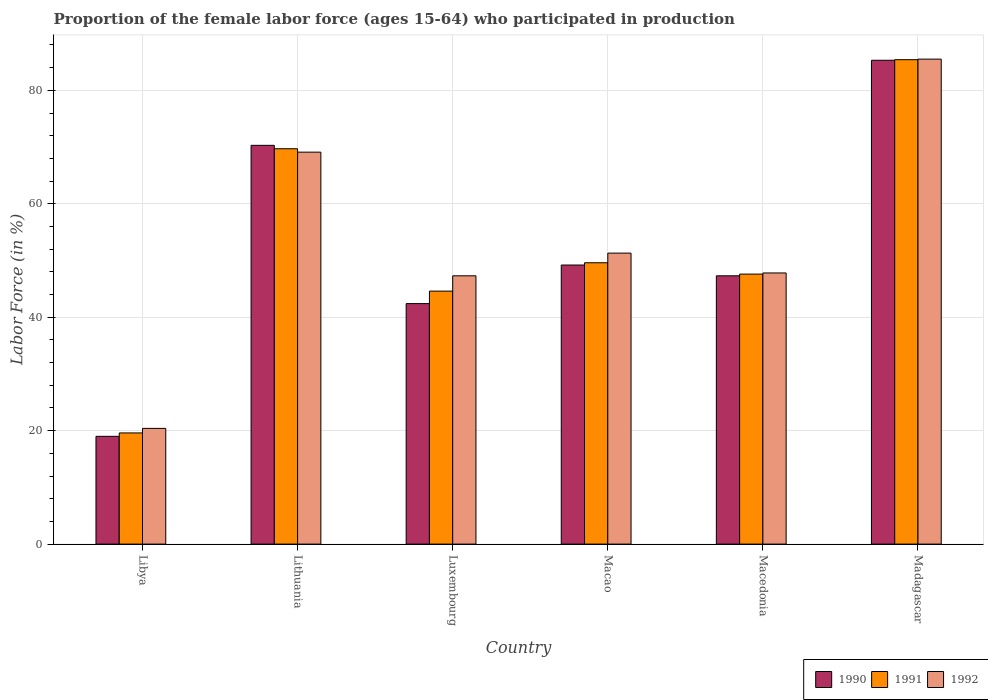How many groups of bars are there?
Give a very brief answer. 6. Are the number of bars per tick equal to the number of legend labels?
Provide a short and direct response. Yes. How many bars are there on the 5th tick from the left?
Your response must be concise. 3. How many bars are there on the 1st tick from the right?
Your answer should be compact. 3. What is the label of the 6th group of bars from the left?
Give a very brief answer. Madagascar. What is the proportion of the female labor force who participated in production in 1992 in Macao?
Provide a succinct answer. 51.3. Across all countries, what is the maximum proportion of the female labor force who participated in production in 1992?
Keep it short and to the point. 85.5. Across all countries, what is the minimum proportion of the female labor force who participated in production in 1991?
Your response must be concise. 19.6. In which country was the proportion of the female labor force who participated in production in 1992 maximum?
Give a very brief answer. Madagascar. In which country was the proportion of the female labor force who participated in production in 1991 minimum?
Your answer should be very brief. Libya. What is the total proportion of the female labor force who participated in production in 1992 in the graph?
Offer a very short reply. 321.4. What is the difference between the proportion of the female labor force who participated in production in 1991 in Luxembourg and that in Madagascar?
Provide a short and direct response. -40.8. What is the difference between the proportion of the female labor force who participated in production in 1992 in Madagascar and the proportion of the female labor force who participated in production in 1990 in Lithuania?
Make the answer very short. 15.2. What is the average proportion of the female labor force who participated in production in 1991 per country?
Your answer should be very brief. 52.75. What is the difference between the proportion of the female labor force who participated in production of/in 1992 and proportion of the female labor force who participated in production of/in 1991 in Macao?
Ensure brevity in your answer.  1.7. In how many countries, is the proportion of the female labor force who participated in production in 1990 greater than 40 %?
Give a very brief answer. 5. What is the ratio of the proportion of the female labor force who participated in production in 1991 in Libya to that in Macedonia?
Your answer should be very brief. 0.41. Is the proportion of the female labor force who participated in production in 1991 in Macedonia less than that in Madagascar?
Ensure brevity in your answer.  Yes. What is the difference between the highest and the second highest proportion of the female labor force who participated in production in 1991?
Your response must be concise. -20.1. What is the difference between the highest and the lowest proportion of the female labor force who participated in production in 1991?
Offer a very short reply. 65.8. In how many countries, is the proportion of the female labor force who participated in production in 1991 greater than the average proportion of the female labor force who participated in production in 1991 taken over all countries?
Your answer should be compact. 2. Is the sum of the proportion of the female labor force who participated in production in 1990 in Lithuania and Madagascar greater than the maximum proportion of the female labor force who participated in production in 1992 across all countries?
Make the answer very short. Yes. Are the values on the major ticks of Y-axis written in scientific E-notation?
Ensure brevity in your answer.  No. How are the legend labels stacked?
Give a very brief answer. Horizontal. What is the title of the graph?
Your answer should be very brief. Proportion of the female labor force (ages 15-64) who participated in production. Does "2010" appear as one of the legend labels in the graph?
Make the answer very short. No. What is the label or title of the Y-axis?
Give a very brief answer. Labor Force (in %). What is the Labor Force (in %) in 1991 in Libya?
Ensure brevity in your answer.  19.6. What is the Labor Force (in %) of 1992 in Libya?
Make the answer very short. 20.4. What is the Labor Force (in %) in 1990 in Lithuania?
Your response must be concise. 70.3. What is the Labor Force (in %) in 1991 in Lithuania?
Your answer should be compact. 69.7. What is the Labor Force (in %) of 1992 in Lithuania?
Make the answer very short. 69.1. What is the Labor Force (in %) of 1990 in Luxembourg?
Your response must be concise. 42.4. What is the Labor Force (in %) of 1991 in Luxembourg?
Your answer should be very brief. 44.6. What is the Labor Force (in %) of 1992 in Luxembourg?
Provide a short and direct response. 47.3. What is the Labor Force (in %) in 1990 in Macao?
Provide a succinct answer. 49.2. What is the Labor Force (in %) in 1991 in Macao?
Make the answer very short. 49.6. What is the Labor Force (in %) in 1992 in Macao?
Give a very brief answer. 51.3. What is the Labor Force (in %) of 1990 in Macedonia?
Give a very brief answer. 47.3. What is the Labor Force (in %) in 1991 in Macedonia?
Offer a very short reply. 47.6. What is the Labor Force (in %) in 1992 in Macedonia?
Make the answer very short. 47.8. What is the Labor Force (in %) in 1990 in Madagascar?
Ensure brevity in your answer.  85.3. What is the Labor Force (in %) in 1991 in Madagascar?
Your response must be concise. 85.4. What is the Labor Force (in %) in 1992 in Madagascar?
Make the answer very short. 85.5. Across all countries, what is the maximum Labor Force (in %) of 1990?
Your answer should be compact. 85.3. Across all countries, what is the maximum Labor Force (in %) of 1991?
Your answer should be compact. 85.4. Across all countries, what is the maximum Labor Force (in %) of 1992?
Make the answer very short. 85.5. Across all countries, what is the minimum Labor Force (in %) of 1990?
Make the answer very short. 19. Across all countries, what is the minimum Labor Force (in %) of 1991?
Your answer should be very brief. 19.6. Across all countries, what is the minimum Labor Force (in %) in 1992?
Your response must be concise. 20.4. What is the total Labor Force (in %) of 1990 in the graph?
Keep it short and to the point. 313.5. What is the total Labor Force (in %) of 1991 in the graph?
Make the answer very short. 316.5. What is the total Labor Force (in %) of 1992 in the graph?
Ensure brevity in your answer.  321.4. What is the difference between the Labor Force (in %) in 1990 in Libya and that in Lithuania?
Keep it short and to the point. -51.3. What is the difference between the Labor Force (in %) of 1991 in Libya and that in Lithuania?
Offer a very short reply. -50.1. What is the difference between the Labor Force (in %) in 1992 in Libya and that in Lithuania?
Your response must be concise. -48.7. What is the difference between the Labor Force (in %) of 1990 in Libya and that in Luxembourg?
Provide a succinct answer. -23.4. What is the difference between the Labor Force (in %) in 1991 in Libya and that in Luxembourg?
Make the answer very short. -25. What is the difference between the Labor Force (in %) in 1992 in Libya and that in Luxembourg?
Ensure brevity in your answer.  -26.9. What is the difference between the Labor Force (in %) in 1990 in Libya and that in Macao?
Offer a terse response. -30.2. What is the difference between the Labor Force (in %) in 1992 in Libya and that in Macao?
Ensure brevity in your answer.  -30.9. What is the difference between the Labor Force (in %) of 1990 in Libya and that in Macedonia?
Ensure brevity in your answer.  -28.3. What is the difference between the Labor Force (in %) in 1991 in Libya and that in Macedonia?
Your response must be concise. -28. What is the difference between the Labor Force (in %) in 1992 in Libya and that in Macedonia?
Make the answer very short. -27.4. What is the difference between the Labor Force (in %) in 1990 in Libya and that in Madagascar?
Keep it short and to the point. -66.3. What is the difference between the Labor Force (in %) of 1991 in Libya and that in Madagascar?
Your answer should be very brief. -65.8. What is the difference between the Labor Force (in %) in 1992 in Libya and that in Madagascar?
Ensure brevity in your answer.  -65.1. What is the difference between the Labor Force (in %) of 1990 in Lithuania and that in Luxembourg?
Offer a terse response. 27.9. What is the difference between the Labor Force (in %) of 1991 in Lithuania and that in Luxembourg?
Keep it short and to the point. 25.1. What is the difference between the Labor Force (in %) of 1992 in Lithuania and that in Luxembourg?
Make the answer very short. 21.8. What is the difference between the Labor Force (in %) of 1990 in Lithuania and that in Macao?
Your answer should be very brief. 21.1. What is the difference between the Labor Force (in %) of 1991 in Lithuania and that in Macao?
Your answer should be very brief. 20.1. What is the difference between the Labor Force (in %) of 1992 in Lithuania and that in Macao?
Give a very brief answer. 17.8. What is the difference between the Labor Force (in %) of 1990 in Lithuania and that in Macedonia?
Give a very brief answer. 23. What is the difference between the Labor Force (in %) in 1991 in Lithuania and that in Macedonia?
Give a very brief answer. 22.1. What is the difference between the Labor Force (in %) of 1992 in Lithuania and that in Macedonia?
Make the answer very short. 21.3. What is the difference between the Labor Force (in %) of 1990 in Lithuania and that in Madagascar?
Keep it short and to the point. -15. What is the difference between the Labor Force (in %) in 1991 in Lithuania and that in Madagascar?
Your answer should be compact. -15.7. What is the difference between the Labor Force (in %) in 1992 in Lithuania and that in Madagascar?
Keep it short and to the point. -16.4. What is the difference between the Labor Force (in %) in 1990 in Luxembourg and that in Macao?
Keep it short and to the point. -6.8. What is the difference between the Labor Force (in %) of 1992 in Luxembourg and that in Macao?
Provide a short and direct response. -4. What is the difference between the Labor Force (in %) of 1990 in Luxembourg and that in Macedonia?
Make the answer very short. -4.9. What is the difference between the Labor Force (in %) in 1990 in Luxembourg and that in Madagascar?
Provide a short and direct response. -42.9. What is the difference between the Labor Force (in %) of 1991 in Luxembourg and that in Madagascar?
Offer a terse response. -40.8. What is the difference between the Labor Force (in %) of 1992 in Luxembourg and that in Madagascar?
Your answer should be compact. -38.2. What is the difference between the Labor Force (in %) of 1991 in Macao and that in Macedonia?
Provide a short and direct response. 2. What is the difference between the Labor Force (in %) of 1990 in Macao and that in Madagascar?
Ensure brevity in your answer.  -36.1. What is the difference between the Labor Force (in %) in 1991 in Macao and that in Madagascar?
Ensure brevity in your answer.  -35.8. What is the difference between the Labor Force (in %) of 1992 in Macao and that in Madagascar?
Your answer should be very brief. -34.2. What is the difference between the Labor Force (in %) in 1990 in Macedonia and that in Madagascar?
Your answer should be compact. -38. What is the difference between the Labor Force (in %) of 1991 in Macedonia and that in Madagascar?
Your answer should be compact. -37.8. What is the difference between the Labor Force (in %) in 1992 in Macedonia and that in Madagascar?
Keep it short and to the point. -37.7. What is the difference between the Labor Force (in %) of 1990 in Libya and the Labor Force (in %) of 1991 in Lithuania?
Keep it short and to the point. -50.7. What is the difference between the Labor Force (in %) in 1990 in Libya and the Labor Force (in %) in 1992 in Lithuania?
Provide a succinct answer. -50.1. What is the difference between the Labor Force (in %) of 1991 in Libya and the Labor Force (in %) of 1992 in Lithuania?
Your answer should be compact. -49.5. What is the difference between the Labor Force (in %) of 1990 in Libya and the Labor Force (in %) of 1991 in Luxembourg?
Your response must be concise. -25.6. What is the difference between the Labor Force (in %) in 1990 in Libya and the Labor Force (in %) in 1992 in Luxembourg?
Your response must be concise. -28.3. What is the difference between the Labor Force (in %) of 1991 in Libya and the Labor Force (in %) of 1992 in Luxembourg?
Your answer should be very brief. -27.7. What is the difference between the Labor Force (in %) in 1990 in Libya and the Labor Force (in %) in 1991 in Macao?
Give a very brief answer. -30.6. What is the difference between the Labor Force (in %) of 1990 in Libya and the Labor Force (in %) of 1992 in Macao?
Offer a terse response. -32.3. What is the difference between the Labor Force (in %) of 1991 in Libya and the Labor Force (in %) of 1992 in Macao?
Offer a very short reply. -31.7. What is the difference between the Labor Force (in %) in 1990 in Libya and the Labor Force (in %) in 1991 in Macedonia?
Offer a very short reply. -28.6. What is the difference between the Labor Force (in %) in 1990 in Libya and the Labor Force (in %) in 1992 in Macedonia?
Offer a very short reply. -28.8. What is the difference between the Labor Force (in %) of 1991 in Libya and the Labor Force (in %) of 1992 in Macedonia?
Your answer should be very brief. -28.2. What is the difference between the Labor Force (in %) in 1990 in Libya and the Labor Force (in %) in 1991 in Madagascar?
Keep it short and to the point. -66.4. What is the difference between the Labor Force (in %) of 1990 in Libya and the Labor Force (in %) of 1992 in Madagascar?
Provide a succinct answer. -66.5. What is the difference between the Labor Force (in %) in 1991 in Libya and the Labor Force (in %) in 1992 in Madagascar?
Your response must be concise. -65.9. What is the difference between the Labor Force (in %) in 1990 in Lithuania and the Labor Force (in %) in 1991 in Luxembourg?
Your answer should be compact. 25.7. What is the difference between the Labor Force (in %) of 1990 in Lithuania and the Labor Force (in %) of 1992 in Luxembourg?
Your answer should be very brief. 23. What is the difference between the Labor Force (in %) of 1991 in Lithuania and the Labor Force (in %) of 1992 in Luxembourg?
Offer a terse response. 22.4. What is the difference between the Labor Force (in %) in 1990 in Lithuania and the Labor Force (in %) in 1991 in Macao?
Your answer should be compact. 20.7. What is the difference between the Labor Force (in %) of 1990 in Lithuania and the Labor Force (in %) of 1992 in Macao?
Your answer should be very brief. 19. What is the difference between the Labor Force (in %) of 1990 in Lithuania and the Labor Force (in %) of 1991 in Macedonia?
Offer a very short reply. 22.7. What is the difference between the Labor Force (in %) of 1991 in Lithuania and the Labor Force (in %) of 1992 in Macedonia?
Provide a succinct answer. 21.9. What is the difference between the Labor Force (in %) in 1990 in Lithuania and the Labor Force (in %) in 1991 in Madagascar?
Your answer should be very brief. -15.1. What is the difference between the Labor Force (in %) in 1990 in Lithuania and the Labor Force (in %) in 1992 in Madagascar?
Offer a very short reply. -15.2. What is the difference between the Labor Force (in %) of 1991 in Lithuania and the Labor Force (in %) of 1992 in Madagascar?
Ensure brevity in your answer.  -15.8. What is the difference between the Labor Force (in %) in 1990 in Luxembourg and the Labor Force (in %) in 1992 in Macao?
Your answer should be compact. -8.9. What is the difference between the Labor Force (in %) in 1990 in Luxembourg and the Labor Force (in %) in 1991 in Macedonia?
Make the answer very short. -5.2. What is the difference between the Labor Force (in %) of 1990 in Luxembourg and the Labor Force (in %) of 1992 in Macedonia?
Your answer should be very brief. -5.4. What is the difference between the Labor Force (in %) in 1990 in Luxembourg and the Labor Force (in %) in 1991 in Madagascar?
Offer a terse response. -43. What is the difference between the Labor Force (in %) of 1990 in Luxembourg and the Labor Force (in %) of 1992 in Madagascar?
Ensure brevity in your answer.  -43.1. What is the difference between the Labor Force (in %) in 1991 in Luxembourg and the Labor Force (in %) in 1992 in Madagascar?
Your answer should be very brief. -40.9. What is the difference between the Labor Force (in %) of 1990 in Macao and the Labor Force (in %) of 1992 in Macedonia?
Offer a terse response. 1.4. What is the difference between the Labor Force (in %) of 1990 in Macao and the Labor Force (in %) of 1991 in Madagascar?
Ensure brevity in your answer.  -36.2. What is the difference between the Labor Force (in %) of 1990 in Macao and the Labor Force (in %) of 1992 in Madagascar?
Ensure brevity in your answer.  -36.3. What is the difference between the Labor Force (in %) in 1991 in Macao and the Labor Force (in %) in 1992 in Madagascar?
Provide a short and direct response. -35.9. What is the difference between the Labor Force (in %) in 1990 in Macedonia and the Labor Force (in %) in 1991 in Madagascar?
Ensure brevity in your answer.  -38.1. What is the difference between the Labor Force (in %) of 1990 in Macedonia and the Labor Force (in %) of 1992 in Madagascar?
Offer a terse response. -38.2. What is the difference between the Labor Force (in %) of 1991 in Macedonia and the Labor Force (in %) of 1992 in Madagascar?
Your response must be concise. -37.9. What is the average Labor Force (in %) of 1990 per country?
Make the answer very short. 52.25. What is the average Labor Force (in %) of 1991 per country?
Your response must be concise. 52.75. What is the average Labor Force (in %) in 1992 per country?
Provide a succinct answer. 53.57. What is the difference between the Labor Force (in %) of 1990 and Labor Force (in %) of 1992 in Libya?
Your answer should be compact. -1.4. What is the difference between the Labor Force (in %) of 1990 and Labor Force (in %) of 1992 in Lithuania?
Make the answer very short. 1.2. What is the difference between the Labor Force (in %) in 1990 and Labor Force (in %) in 1991 in Luxembourg?
Provide a short and direct response. -2.2. What is the difference between the Labor Force (in %) in 1991 and Labor Force (in %) in 1992 in Luxembourg?
Offer a very short reply. -2.7. What is the difference between the Labor Force (in %) of 1991 and Labor Force (in %) of 1992 in Macao?
Your answer should be compact. -1.7. What is the difference between the Labor Force (in %) in 1990 and Labor Force (in %) in 1991 in Macedonia?
Make the answer very short. -0.3. What is the difference between the Labor Force (in %) in 1991 and Labor Force (in %) in 1992 in Macedonia?
Your answer should be compact. -0.2. What is the difference between the Labor Force (in %) of 1990 and Labor Force (in %) of 1991 in Madagascar?
Offer a terse response. -0.1. What is the ratio of the Labor Force (in %) of 1990 in Libya to that in Lithuania?
Give a very brief answer. 0.27. What is the ratio of the Labor Force (in %) in 1991 in Libya to that in Lithuania?
Your answer should be compact. 0.28. What is the ratio of the Labor Force (in %) of 1992 in Libya to that in Lithuania?
Give a very brief answer. 0.3. What is the ratio of the Labor Force (in %) in 1990 in Libya to that in Luxembourg?
Your response must be concise. 0.45. What is the ratio of the Labor Force (in %) in 1991 in Libya to that in Luxembourg?
Ensure brevity in your answer.  0.44. What is the ratio of the Labor Force (in %) of 1992 in Libya to that in Luxembourg?
Provide a short and direct response. 0.43. What is the ratio of the Labor Force (in %) of 1990 in Libya to that in Macao?
Ensure brevity in your answer.  0.39. What is the ratio of the Labor Force (in %) of 1991 in Libya to that in Macao?
Provide a short and direct response. 0.4. What is the ratio of the Labor Force (in %) of 1992 in Libya to that in Macao?
Keep it short and to the point. 0.4. What is the ratio of the Labor Force (in %) in 1990 in Libya to that in Macedonia?
Ensure brevity in your answer.  0.4. What is the ratio of the Labor Force (in %) of 1991 in Libya to that in Macedonia?
Keep it short and to the point. 0.41. What is the ratio of the Labor Force (in %) of 1992 in Libya to that in Macedonia?
Your answer should be very brief. 0.43. What is the ratio of the Labor Force (in %) of 1990 in Libya to that in Madagascar?
Your answer should be compact. 0.22. What is the ratio of the Labor Force (in %) of 1991 in Libya to that in Madagascar?
Your response must be concise. 0.23. What is the ratio of the Labor Force (in %) of 1992 in Libya to that in Madagascar?
Keep it short and to the point. 0.24. What is the ratio of the Labor Force (in %) of 1990 in Lithuania to that in Luxembourg?
Ensure brevity in your answer.  1.66. What is the ratio of the Labor Force (in %) in 1991 in Lithuania to that in Luxembourg?
Provide a short and direct response. 1.56. What is the ratio of the Labor Force (in %) in 1992 in Lithuania to that in Luxembourg?
Your answer should be very brief. 1.46. What is the ratio of the Labor Force (in %) in 1990 in Lithuania to that in Macao?
Make the answer very short. 1.43. What is the ratio of the Labor Force (in %) in 1991 in Lithuania to that in Macao?
Offer a very short reply. 1.41. What is the ratio of the Labor Force (in %) in 1992 in Lithuania to that in Macao?
Your answer should be compact. 1.35. What is the ratio of the Labor Force (in %) of 1990 in Lithuania to that in Macedonia?
Your answer should be very brief. 1.49. What is the ratio of the Labor Force (in %) in 1991 in Lithuania to that in Macedonia?
Make the answer very short. 1.46. What is the ratio of the Labor Force (in %) in 1992 in Lithuania to that in Macedonia?
Make the answer very short. 1.45. What is the ratio of the Labor Force (in %) of 1990 in Lithuania to that in Madagascar?
Offer a very short reply. 0.82. What is the ratio of the Labor Force (in %) in 1991 in Lithuania to that in Madagascar?
Your response must be concise. 0.82. What is the ratio of the Labor Force (in %) of 1992 in Lithuania to that in Madagascar?
Your answer should be compact. 0.81. What is the ratio of the Labor Force (in %) of 1990 in Luxembourg to that in Macao?
Provide a succinct answer. 0.86. What is the ratio of the Labor Force (in %) in 1991 in Luxembourg to that in Macao?
Make the answer very short. 0.9. What is the ratio of the Labor Force (in %) of 1992 in Luxembourg to that in Macao?
Make the answer very short. 0.92. What is the ratio of the Labor Force (in %) of 1990 in Luxembourg to that in Macedonia?
Ensure brevity in your answer.  0.9. What is the ratio of the Labor Force (in %) in 1991 in Luxembourg to that in Macedonia?
Your response must be concise. 0.94. What is the ratio of the Labor Force (in %) in 1992 in Luxembourg to that in Macedonia?
Keep it short and to the point. 0.99. What is the ratio of the Labor Force (in %) in 1990 in Luxembourg to that in Madagascar?
Provide a short and direct response. 0.5. What is the ratio of the Labor Force (in %) of 1991 in Luxembourg to that in Madagascar?
Your response must be concise. 0.52. What is the ratio of the Labor Force (in %) of 1992 in Luxembourg to that in Madagascar?
Provide a short and direct response. 0.55. What is the ratio of the Labor Force (in %) in 1990 in Macao to that in Macedonia?
Your answer should be compact. 1.04. What is the ratio of the Labor Force (in %) in 1991 in Macao to that in Macedonia?
Your response must be concise. 1.04. What is the ratio of the Labor Force (in %) in 1992 in Macao to that in Macedonia?
Provide a short and direct response. 1.07. What is the ratio of the Labor Force (in %) in 1990 in Macao to that in Madagascar?
Your answer should be very brief. 0.58. What is the ratio of the Labor Force (in %) in 1991 in Macao to that in Madagascar?
Provide a succinct answer. 0.58. What is the ratio of the Labor Force (in %) of 1992 in Macao to that in Madagascar?
Your answer should be very brief. 0.6. What is the ratio of the Labor Force (in %) in 1990 in Macedonia to that in Madagascar?
Make the answer very short. 0.55. What is the ratio of the Labor Force (in %) of 1991 in Macedonia to that in Madagascar?
Keep it short and to the point. 0.56. What is the ratio of the Labor Force (in %) of 1992 in Macedonia to that in Madagascar?
Give a very brief answer. 0.56. What is the difference between the highest and the lowest Labor Force (in %) in 1990?
Ensure brevity in your answer.  66.3. What is the difference between the highest and the lowest Labor Force (in %) in 1991?
Provide a short and direct response. 65.8. What is the difference between the highest and the lowest Labor Force (in %) of 1992?
Make the answer very short. 65.1. 